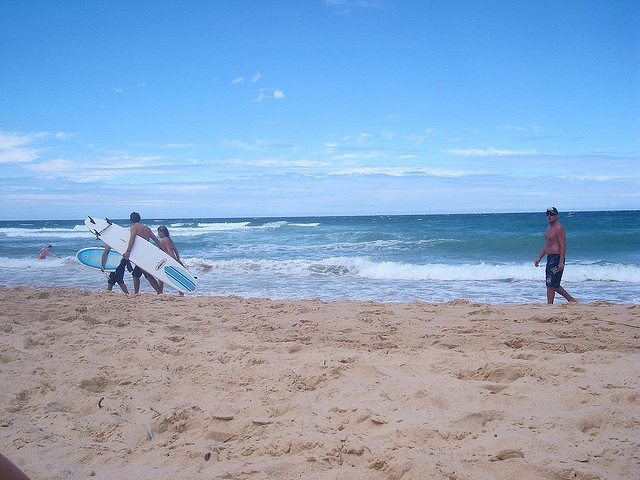Describe the objects in this image and their specific colors. I can see surfboard in gray, lightblue, lavender, and darkgray tones, people in gray, purple, navy, and black tones, people in gray, purple, navy, and darkblue tones, surfboard in gray, lightblue, and blue tones, and people in gray, navy, and darkblue tones in this image. 